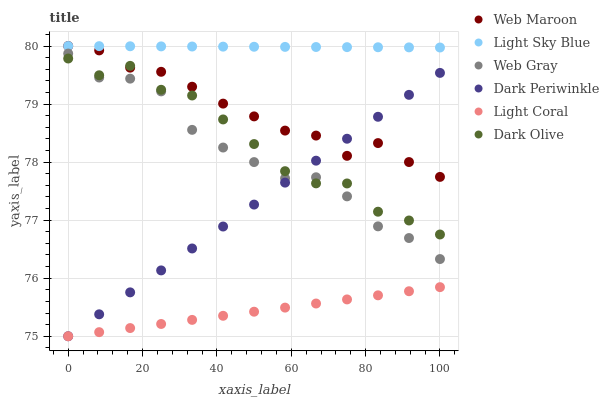Does Light Coral have the minimum area under the curve?
Answer yes or no. Yes. Does Light Sky Blue have the maximum area under the curve?
Answer yes or no. Yes. Does Dark Olive have the minimum area under the curve?
Answer yes or no. No. Does Dark Olive have the maximum area under the curve?
Answer yes or no. No. Is Dark Periwinkle the smoothest?
Answer yes or no. Yes. Is Dark Olive the roughest?
Answer yes or no. Yes. Is Web Maroon the smoothest?
Answer yes or no. No. Is Web Maroon the roughest?
Answer yes or no. No. Does Light Coral have the lowest value?
Answer yes or no. Yes. Does Dark Olive have the lowest value?
Answer yes or no. No. Does Light Sky Blue have the highest value?
Answer yes or no. Yes. Does Dark Olive have the highest value?
Answer yes or no. No. Is Dark Periwinkle less than Light Sky Blue?
Answer yes or no. Yes. Is Light Sky Blue greater than Dark Periwinkle?
Answer yes or no. Yes. Does Dark Periwinkle intersect Web Gray?
Answer yes or no. Yes. Is Dark Periwinkle less than Web Gray?
Answer yes or no. No. Is Dark Periwinkle greater than Web Gray?
Answer yes or no. No. Does Dark Periwinkle intersect Light Sky Blue?
Answer yes or no. No. 